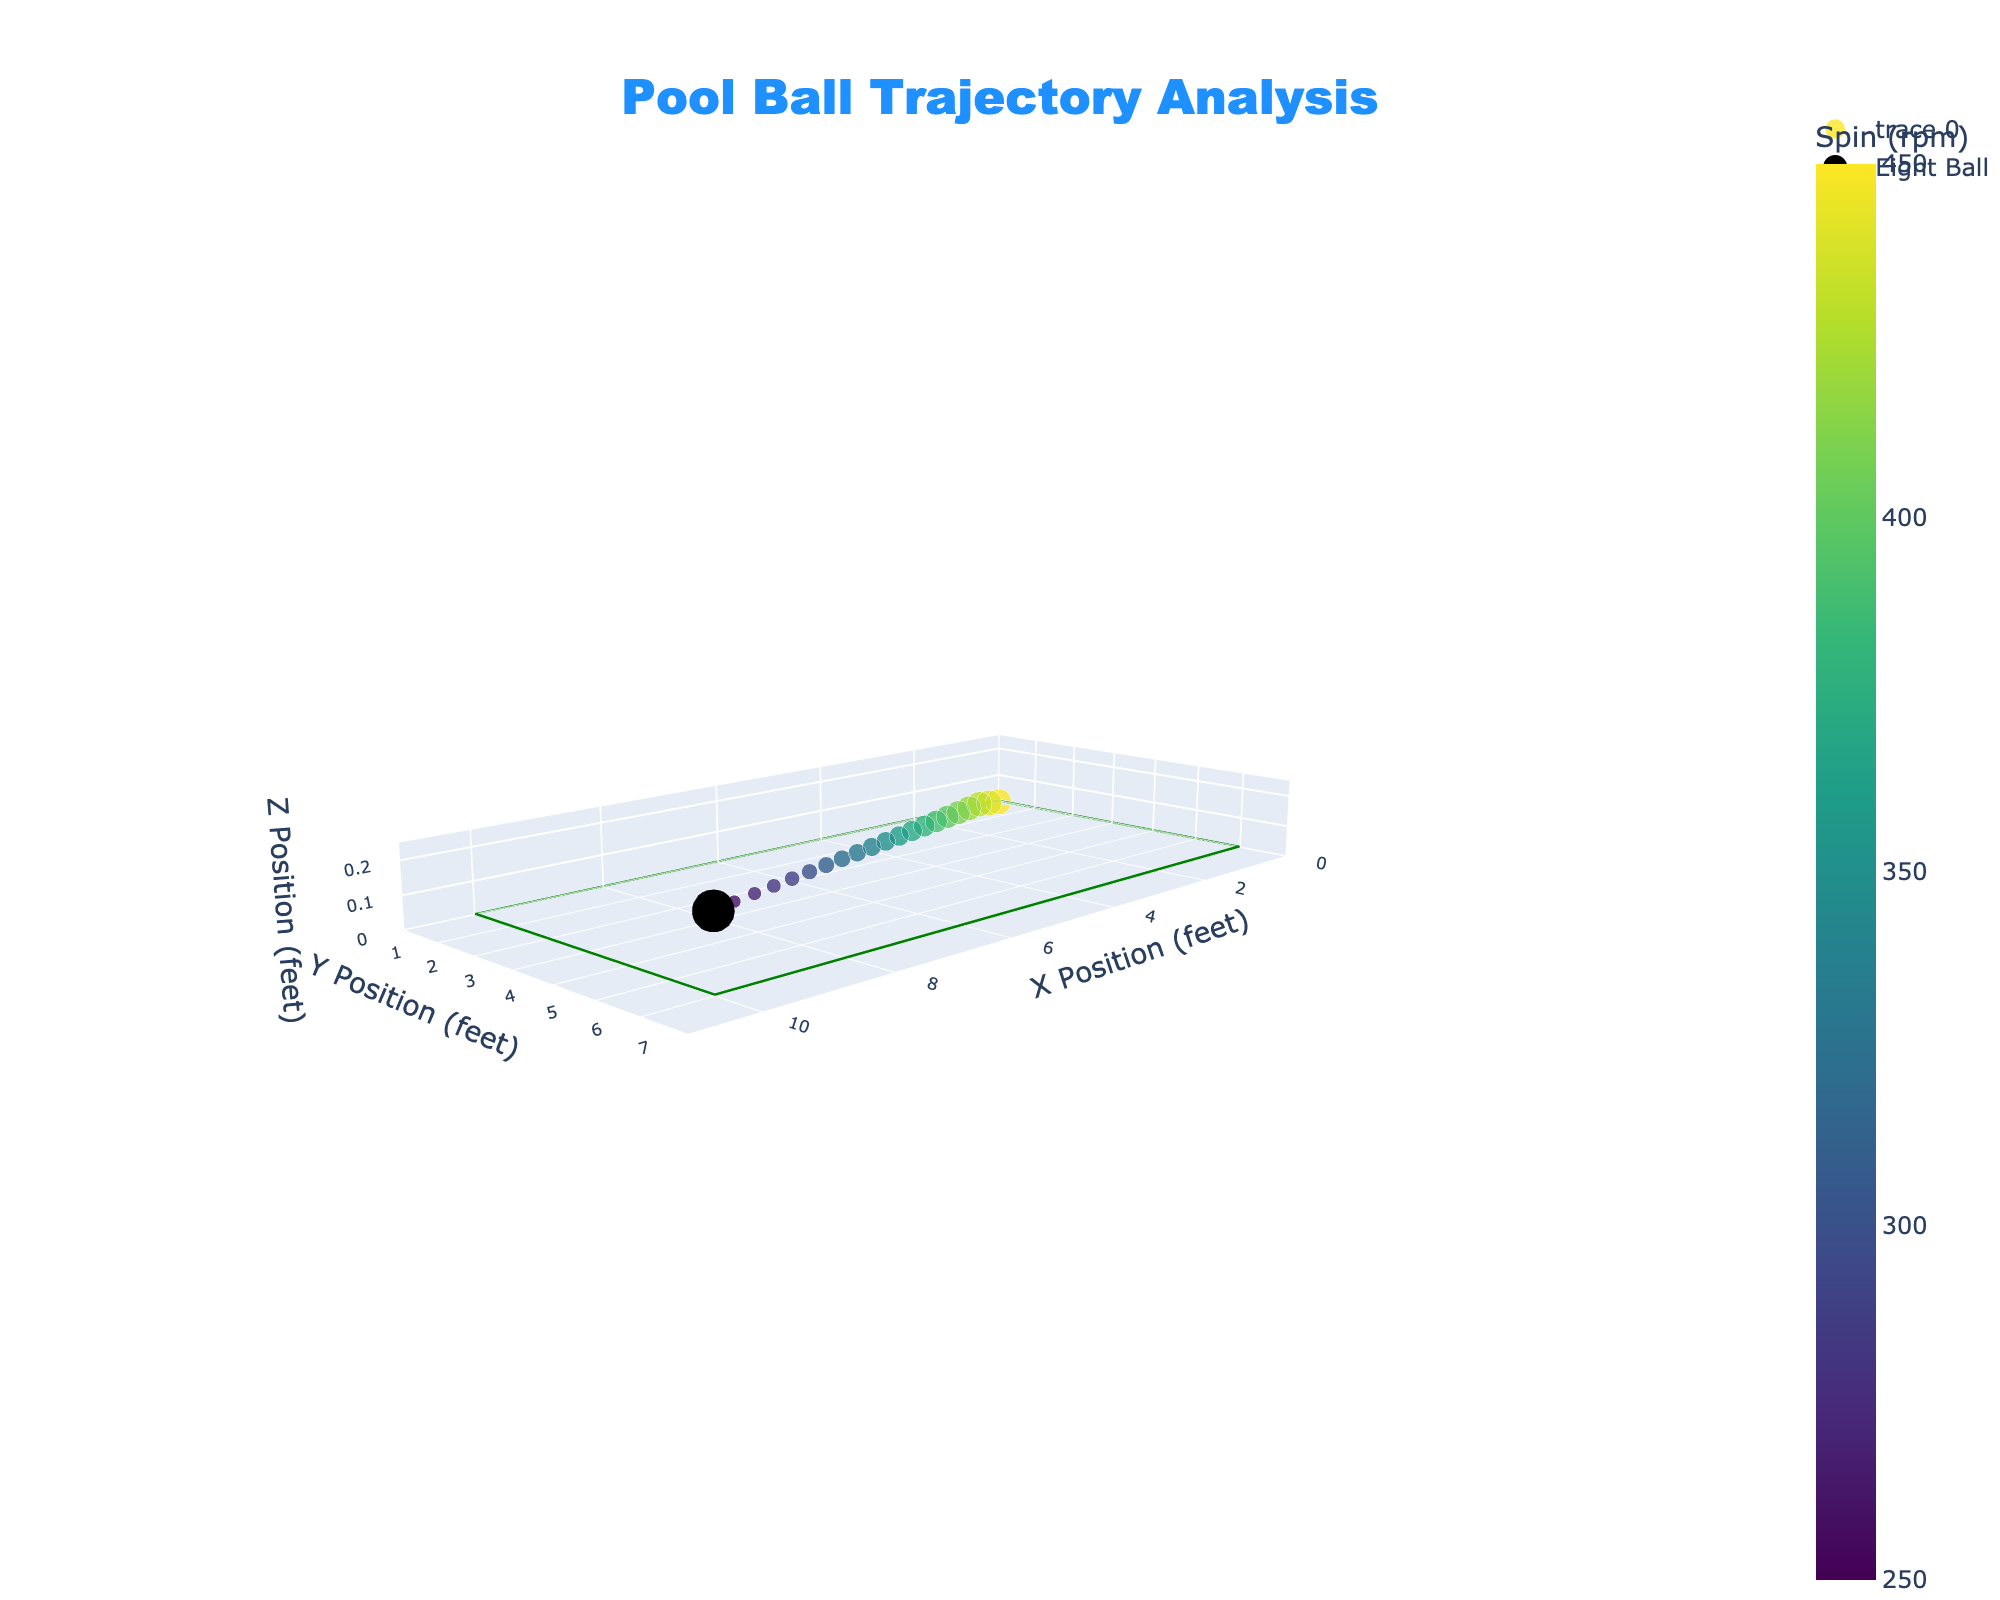What is the color assigned to the eight ball? The eight ball is highlighted in black on the plot, indicating a unique value or category.
Answer: Black What is the title of the plot? The plot's title is displayed at the top and it reads "Pool Ball Trajectory Analysis."
Answer: Pool Ball Trajectory Analysis How is the size of the markers determined? The size of the markers is proportional to the velocity of the ball; higher velocities result in larger markers.
Answer: Proportional to velocity What is the value of the spin for the cue ball at the position (10, 6, 0.22)? By finding the cue ball at coordinates (10, 6, 0.22) on the plot, the value of spin can be seen as indicated by the color scale. Here, the spin value for the cue ball is 250 rpm.
Answer: 250 rpm What rotational speed does the cue ball have at the initial position (0, 0, 0)? Looking at the initial position of the cue ball at (0, 0, 0), the spin can be inferred from the marker's color, which corresponds to a value of 450 rpm.
Answer: 450 rpm What are the axis titles of the plot? The titles for the axes are located next to each axis. The x-axis is "X Position (feet)", the y-axis is "Y Position (feet)", and the z-axis is "Z Position (feet)".
Answer: X Position (feet), Y Position (feet), Z Position (feet) Which ball has the lowest velocity? By observing the marker sizes, the eight ball at (10, 6, 0.22) appears to have the smallest size, indicating the lowest velocity at 3.4.
Answer: Eight ball How does the velocity vary as the cue ball moves? Observing from the initial position to the final cue ball position, the marker sizes decrease, indicating a reduction in velocity from 7.2 to 3.6 ft/s.
Answer: Decreases Is there a trend in the spin values of the cue ball as it progresses on its path? By seeing the color transition from brighter to darker along the cue ball's path, the spin value decreases gradually from 450 rpm to 270 rpm.
Answer: Decreases What does the color scale represent in this plot? The color scale on the plot indicates the spin of the pool balls in rpm, with colors transitioning from bright to dark shades.
Answer: Spin in rpm 